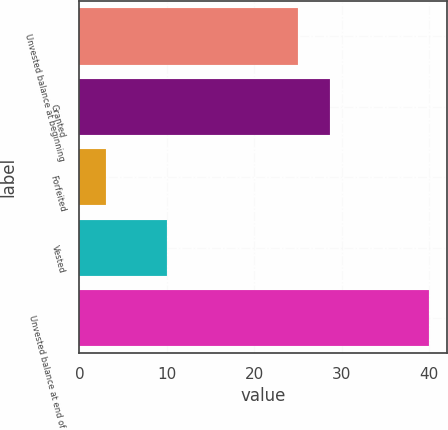Convert chart to OTSL. <chart><loc_0><loc_0><loc_500><loc_500><bar_chart><fcel>Unvested balance at beginning<fcel>Granted<fcel>Forfeited<fcel>Vested<fcel>Unvested balance at end of<nl><fcel>25<fcel>28.7<fcel>3<fcel>10<fcel>40<nl></chart> 